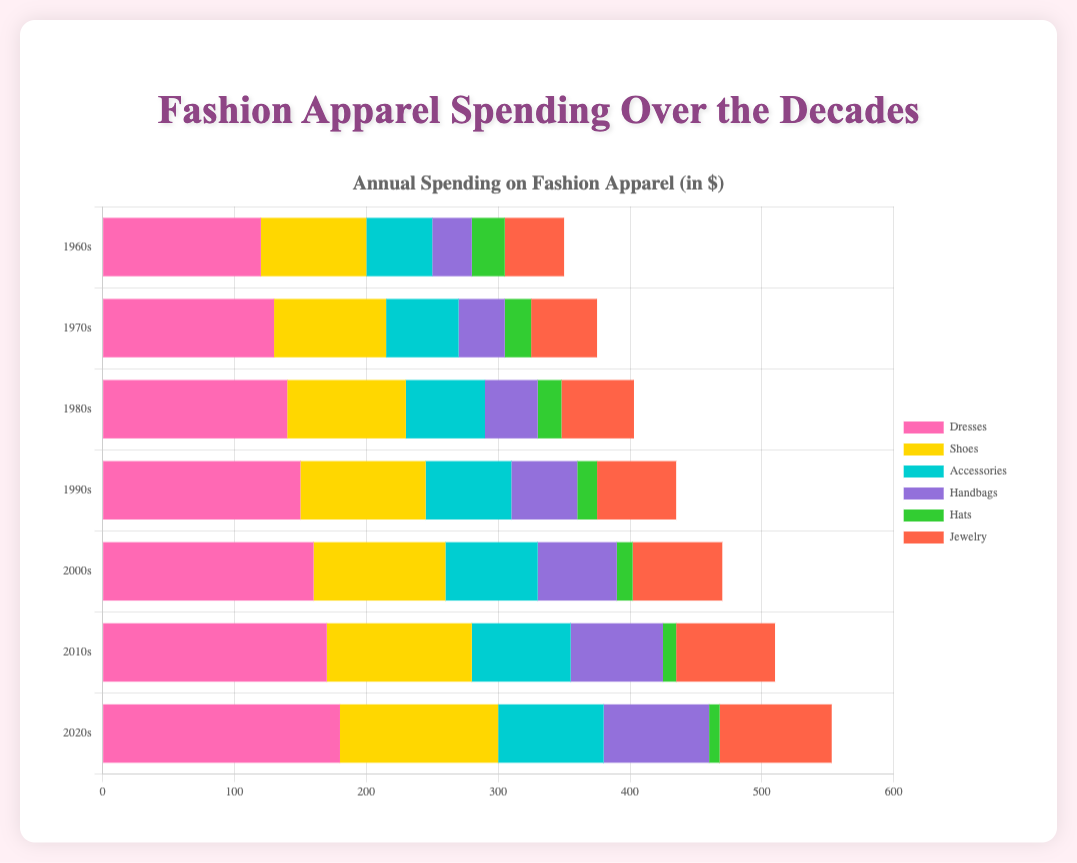What was the total spending on Dresses and Shoes in the 2010s? To calculate the total spending on Dresses and Shoes in the 2010s, add the spending on Dresses ($170) and Shoes ($110): 170 + 110 = 280
Answer: 280 Which decade saw the highest spending on Hats? To find the highest spending on Hats, look at the spending values for Hats across all decades: 1960s ($25), 1970s ($20), 1980s ($18), 1990s ($15), 2000s ($12), 2010s ($10), 2020s ($8). The highest is in the 1960s.
Answer: 1960s How does the spending on Accessories in the 2020s compare to the 1980s? The spending on Accessories in the 2020s is $80, and in the 1980s it was $60. Comparing these, $80 is greater than $60, so there's an increase.
Answer: Accessories spending increased from 1980s to 2020s What is the difference in spending on Handbags between the 2000s and the 1970s? Subtract the 1970s Handbags spending ($35) from the 2000s Handbags spending ($60): 60 - 35 = 25
Answer: 25 Which category had the smallest increase in spending from the 1960s to the 2020s? For each category, calculate the increase: Dresses (180 - 120 = 60), Shoes (120 - 80 = 40), Accessories (80 - 50 = 30), Handbags (80 - 30 = 50), Hats (8 - 25 = -17), Jewelry (85 - 45 = 40). The smallest increase (actually a decrease) is in Hats with -17.
Answer: Hats What is the average spending on Jewelry across all decades? Add the Jewelry spending values across all decades and divide by the number of decades: (45 + 50 + 55 + 60 + 68 + 75 + 85) / 7 = 438 / 7 = 62.57
Answer: 62.57 Did spending on Jewelry increase, decrease, or stay the same from the 1990s to the 2010s? Compare the spending on Jewelry in the 1990s ($60) and the 2010s ($75). $75 is greater than $60, meaning the spending increased.
Answer: Increased What was the total spending on all fashion categories in the 1960s? Sum the spending on all categories in the 1960s: 120 (Dresses) + 80 (Shoes) + 50 (Accessories) + 30 (Handbags) + 25 (Hats) + 45 (Jewelry) = 350
Answer: 350 Which category saw the most consistent increase in spending over the decades? Compare the spending values for each category over the decades and identify which consistently increases: Dresses consistently increase from 120 to 180, Shoes from 80 to 120, and so forth. Dresses have no fluctuation and thus the most consistent increase.
Answer: Dresses 